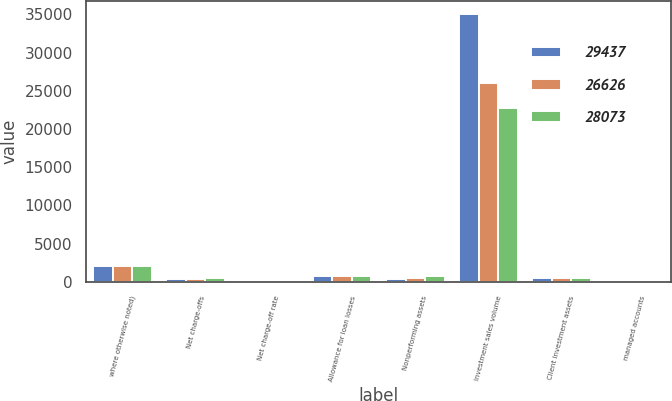<chart> <loc_0><loc_0><loc_500><loc_500><stacked_bar_chart><ecel><fcel>where otherwise noted)<fcel>Net charge-offs<fcel>Net charge-off rate<fcel>Allowance for loan losses<fcel>Nonperforming assets<fcel>Investment sales volume<fcel>Client investment assets<fcel>managed accounts<nl><fcel>29437<fcel>2013<fcel>337<fcel>1.79<fcel>707<fcel>391<fcel>35050<fcel>494<fcel>36<nl><fcel>26626<fcel>2012<fcel>411<fcel>2.27<fcel>698<fcel>488<fcel>26036<fcel>494<fcel>29<nl><fcel>28073<fcel>2011<fcel>494<fcel>2.89<fcel>798<fcel>710<fcel>22716<fcel>494<fcel>24<nl></chart> 